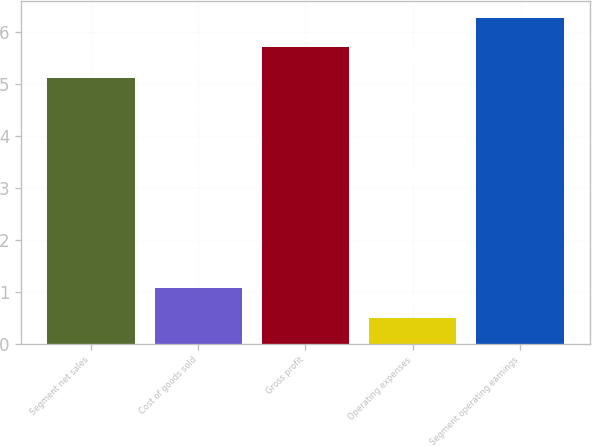Convert chart. <chart><loc_0><loc_0><loc_500><loc_500><bar_chart><fcel>Segment net sales<fcel>Cost of goods sold<fcel>Gross profit<fcel>Operating expenses<fcel>Segment operating earnings<nl><fcel>5.1<fcel>1.07<fcel>5.7<fcel>0.5<fcel>6.27<nl></chart> 